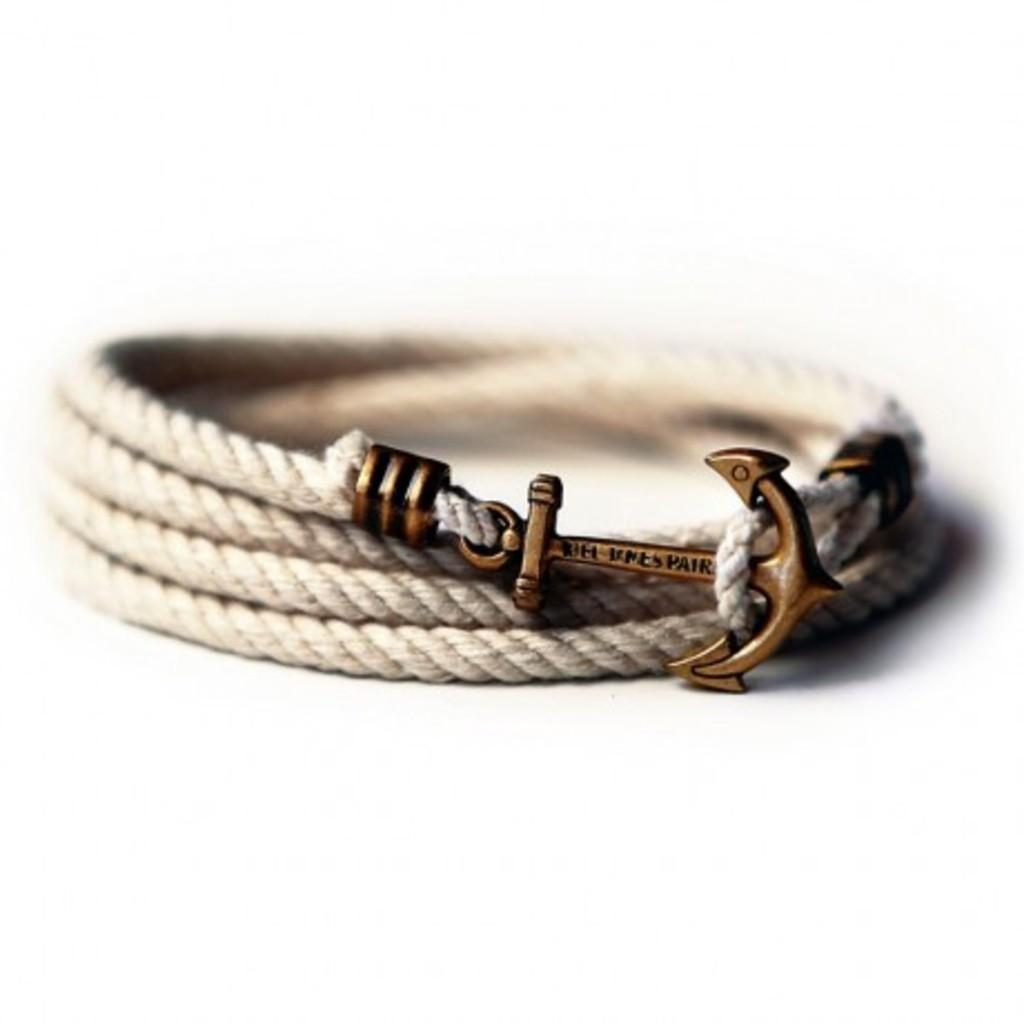What type of accessory is visible in the image? There is a bracelet in the image. What type of meal is being prepared in the image? There is no meal being prepared in the image; it only features a bracelet. How much sugar is present in the bracelet in the image? There is no sugar present in the bracelet in the image, as it is an accessory and not a food item. 